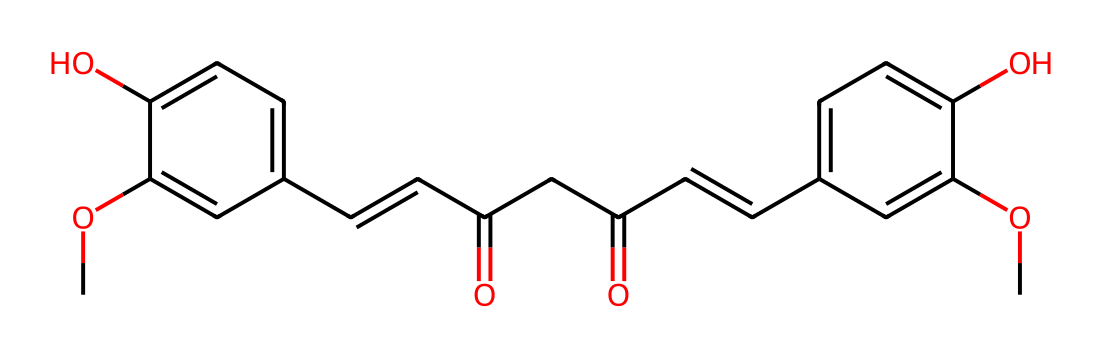What is the main functional group present in this chemical? The chemical structure includes an ether (-O-) and several hydroxyl (-OH) groups, indicating the presence of phenols.
Answer: phenol How many carbon atoms are present in this chemical? By counting the carbon atoms in the SMILES representation, a total of 21 carbon atoms can be identified.
Answer: 21 What type of dye is this compound classified as? This compound is classified as a natural dye due to its origin from turmeric, which is a plant source.
Answer: natural dye What can this compound indicate about the color it produces? The presence of the conjugated double bonds and specific functional groups typically correlates with its yellow coloration, associated with curcumin.
Answer: yellow How many hydroxyl groups (-OH) are present in this chemical? By examining the SMILES, there are a total of 4 hydroxyl groups depicted, corresponding to their presence in the structure.
Answer: 4 What is the impact of this compound's structure on its water solubility? The presence of multiple hydroxyl groups enhances water solubility due to hydrogen bonding, which allows for easier dispersal in aqueous solutions.
Answer: increases solubility 